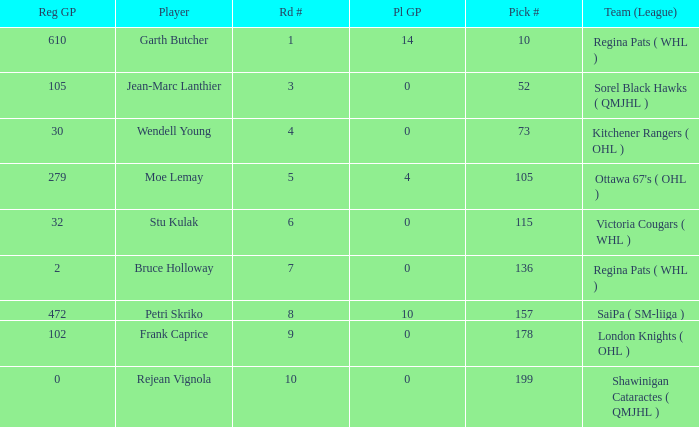What is the mean road number when Moe Lemay is the player? 5.0. 